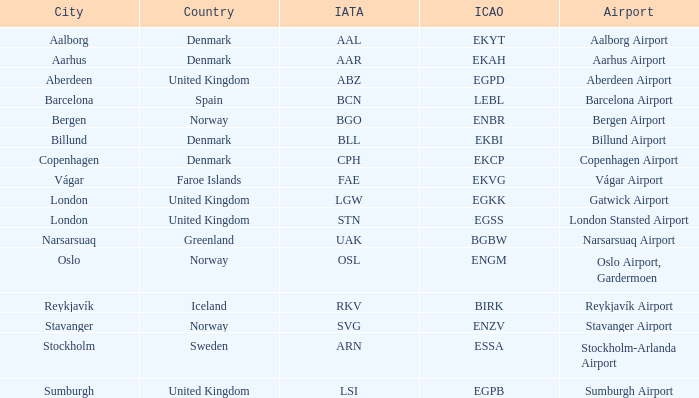What country has an ICAO of ENZV? Norway. 